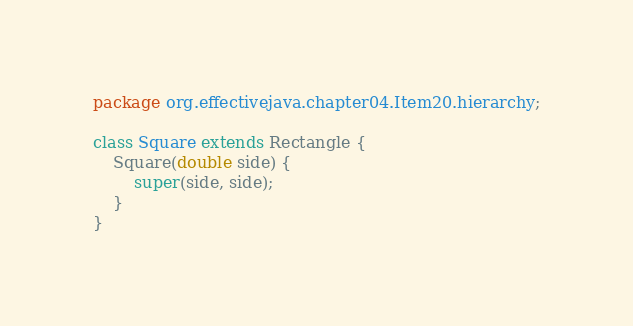Convert code to text. <code><loc_0><loc_0><loc_500><loc_500><_Java_>package org.effectivejava.chapter04.Item20.hierarchy;

class Square extends Rectangle {
	Square(double side) {
		super(side, side);
	}
}
</code> 